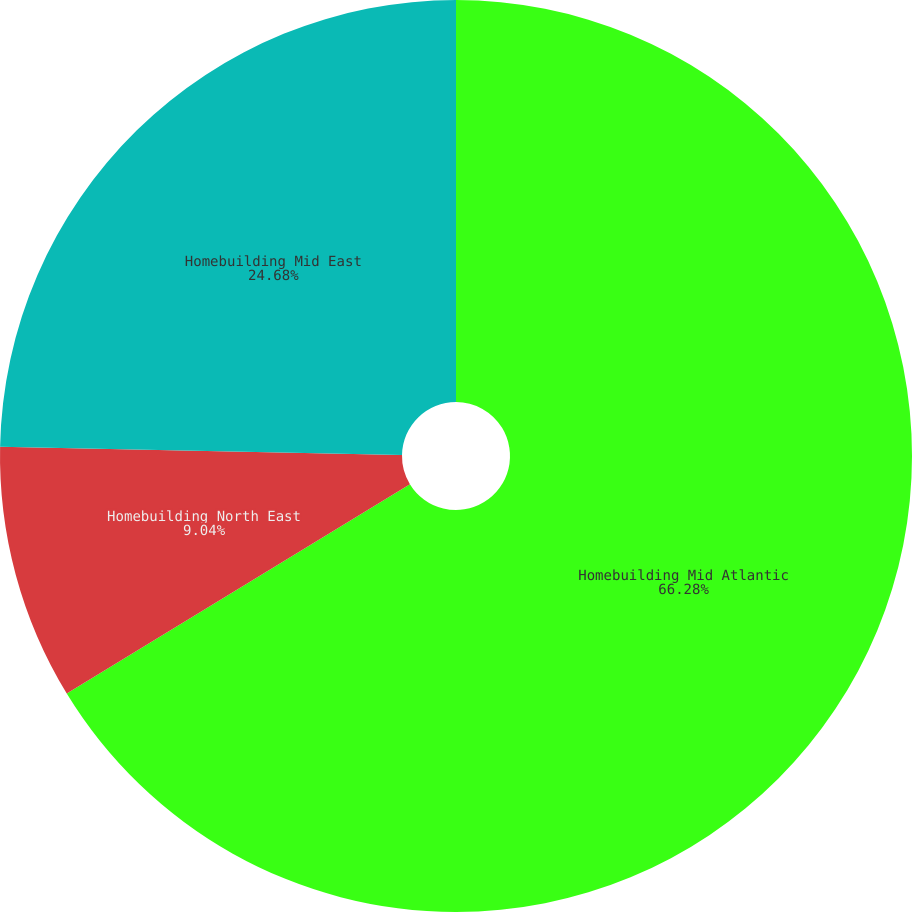<chart> <loc_0><loc_0><loc_500><loc_500><pie_chart><fcel>Homebuilding Mid Atlantic<fcel>Homebuilding North East<fcel>Homebuilding Mid East<nl><fcel>66.28%<fcel>9.04%<fcel>24.68%<nl></chart> 